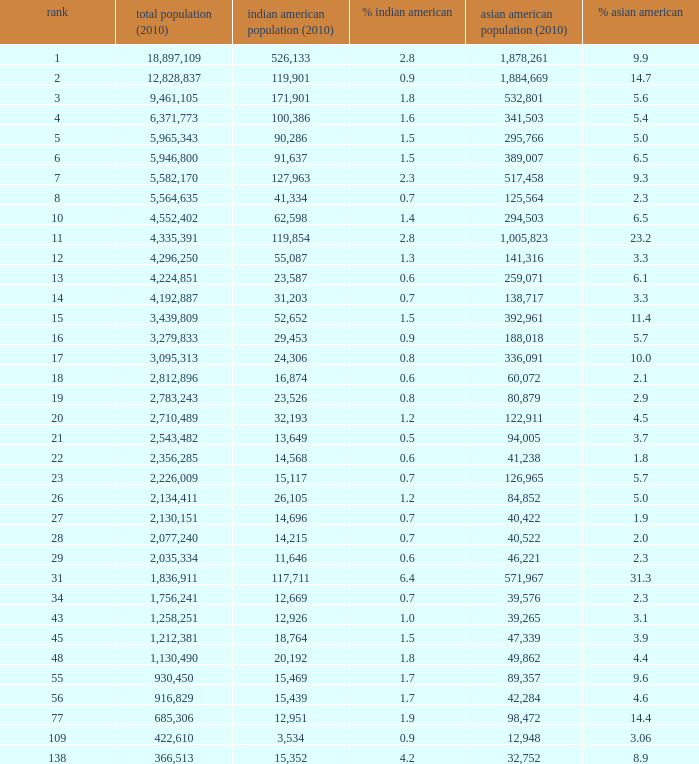What's the total population when there are 5.7% Asian American and fewer than 126,965 Asian American Population? None. 